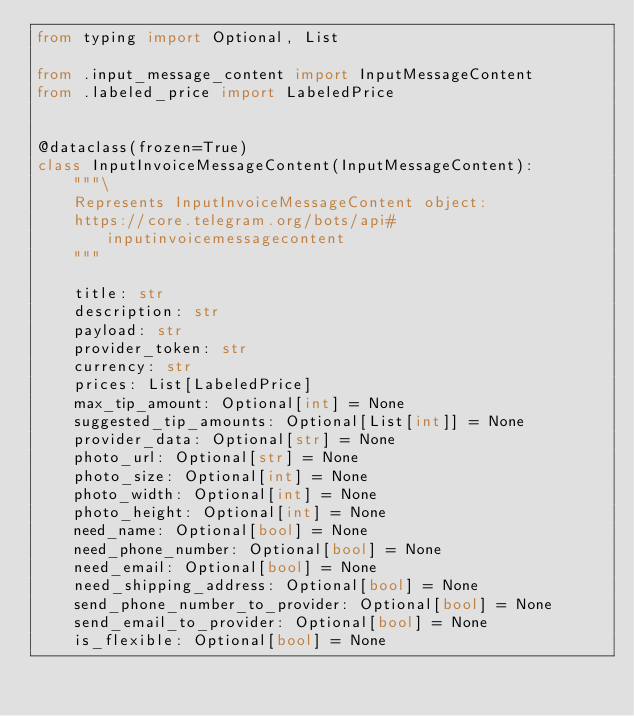Convert code to text. <code><loc_0><loc_0><loc_500><loc_500><_Python_>from typing import Optional, List

from .input_message_content import InputMessageContent
from .labeled_price import LabeledPrice


@dataclass(frozen=True)
class InputInvoiceMessageContent(InputMessageContent):
    """\
    Represents InputInvoiceMessageContent object:
    https://core.telegram.org/bots/api#inputinvoicemessagecontent
    """

    title: str
    description: str
    payload: str
    provider_token: str
    currency: str
    prices: List[LabeledPrice]
    max_tip_amount: Optional[int] = None
    suggested_tip_amounts: Optional[List[int]] = None
    provider_data: Optional[str] = None
    photo_url: Optional[str] = None
    photo_size: Optional[int] = None
    photo_width: Optional[int] = None
    photo_height: Optional[int] = None
    need_name: Optional[bool] = None
    need_phone_number: Optional[bool] = None
    need_email: Optional[bool] = None
    need_shipping_address: Optional[bool] = None
    send_phone_number_to_provider: Optional[bool] = None
    send_email_to_provider: Optional[bool] = None
    is_flexible: Optional[bool] = None
</code> 